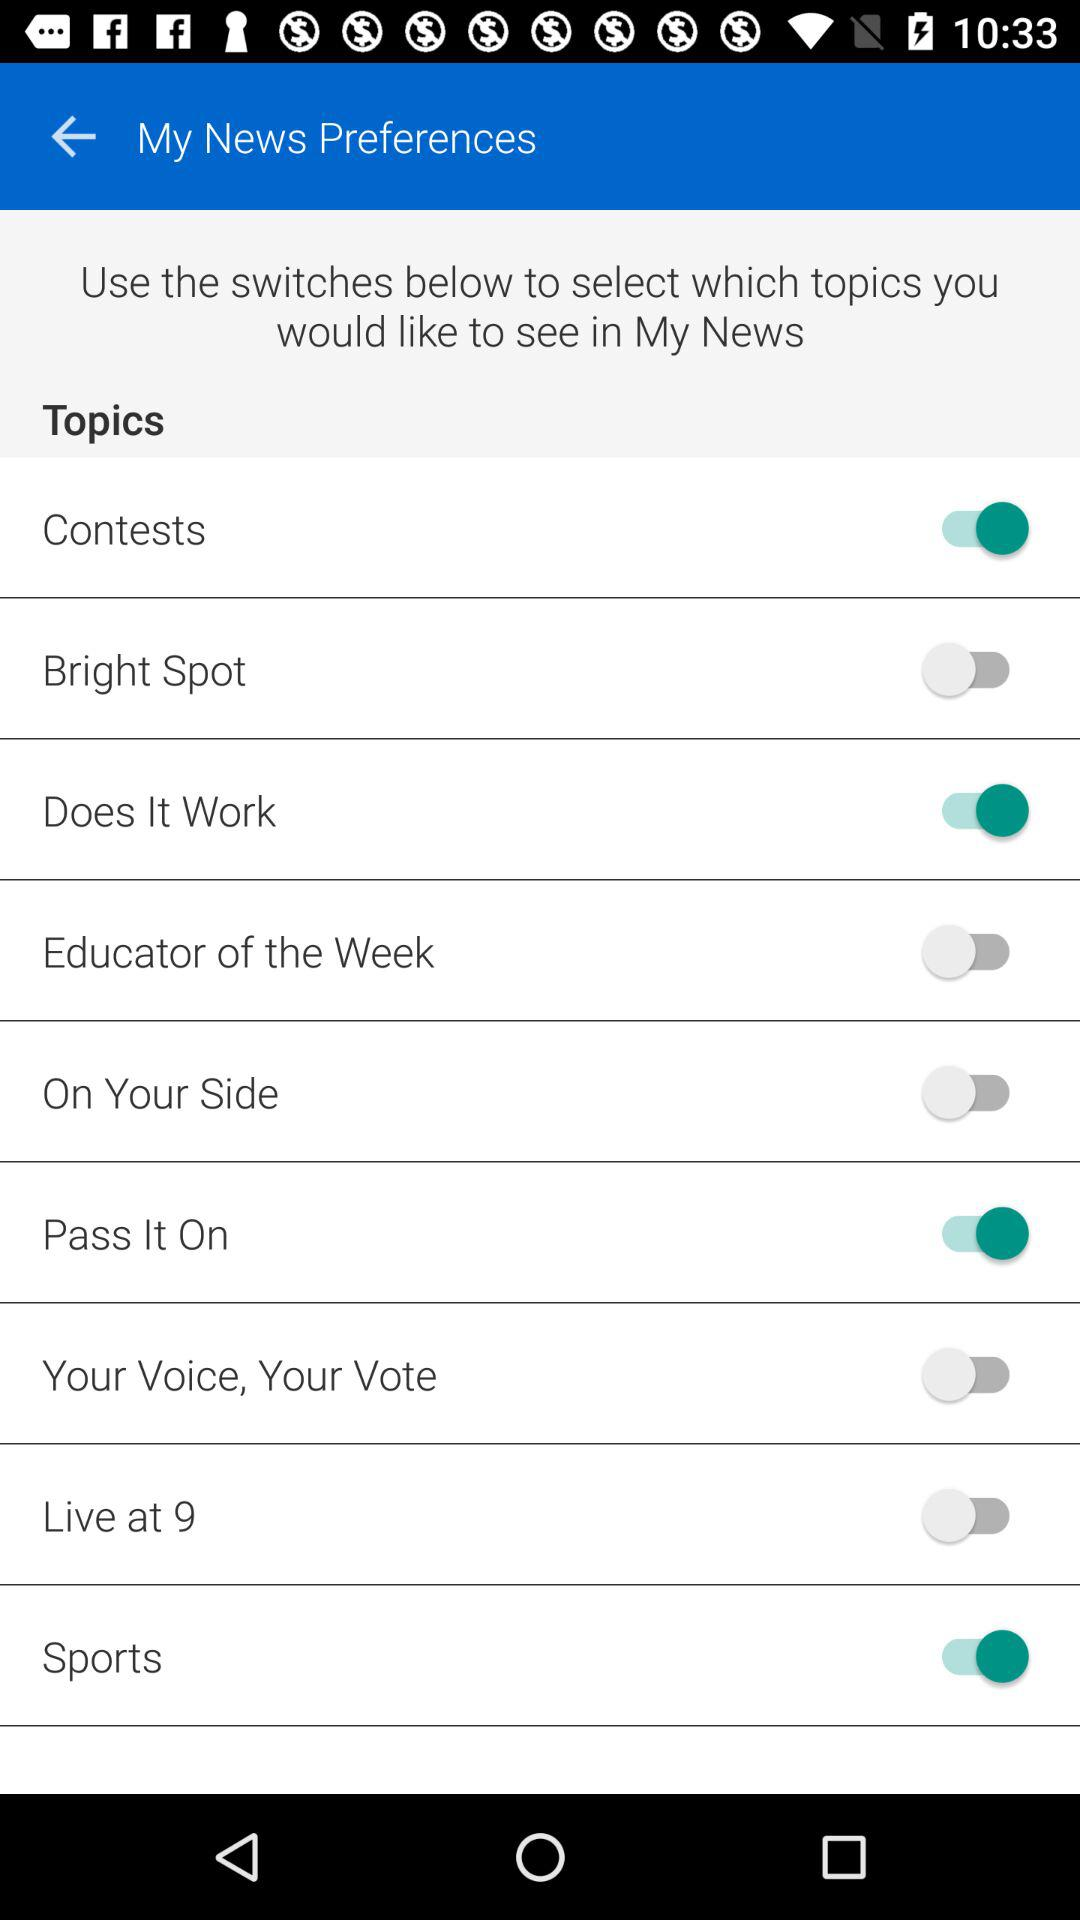What is the status of the "Contests"? The status of the "Contests" is "on". 